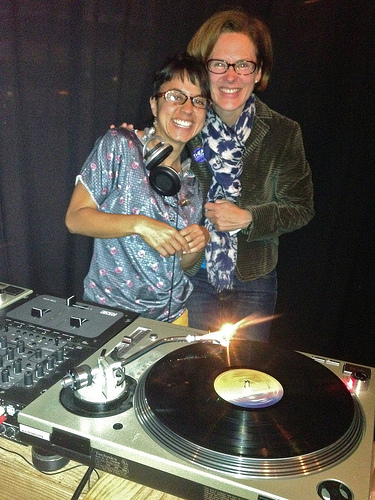<image>
Is the scarf on the tall person? Yes. Looking at the image, I can see the scarf is positioned on top of the tall person, with the tall person providing support. Is the dj on the turntable? No. The dj is not positioned on the turntable. They may be near each other, but the dj is not supported by or resting on top of the turntable. Is there a man to the left of the man? No. The man is not to the left of the man. From this viewpoint, they have a different horizontal relationship. Is the woman above the table? No. The woman is not positioned above the table. The vertical arrangement shows a different relationship. 